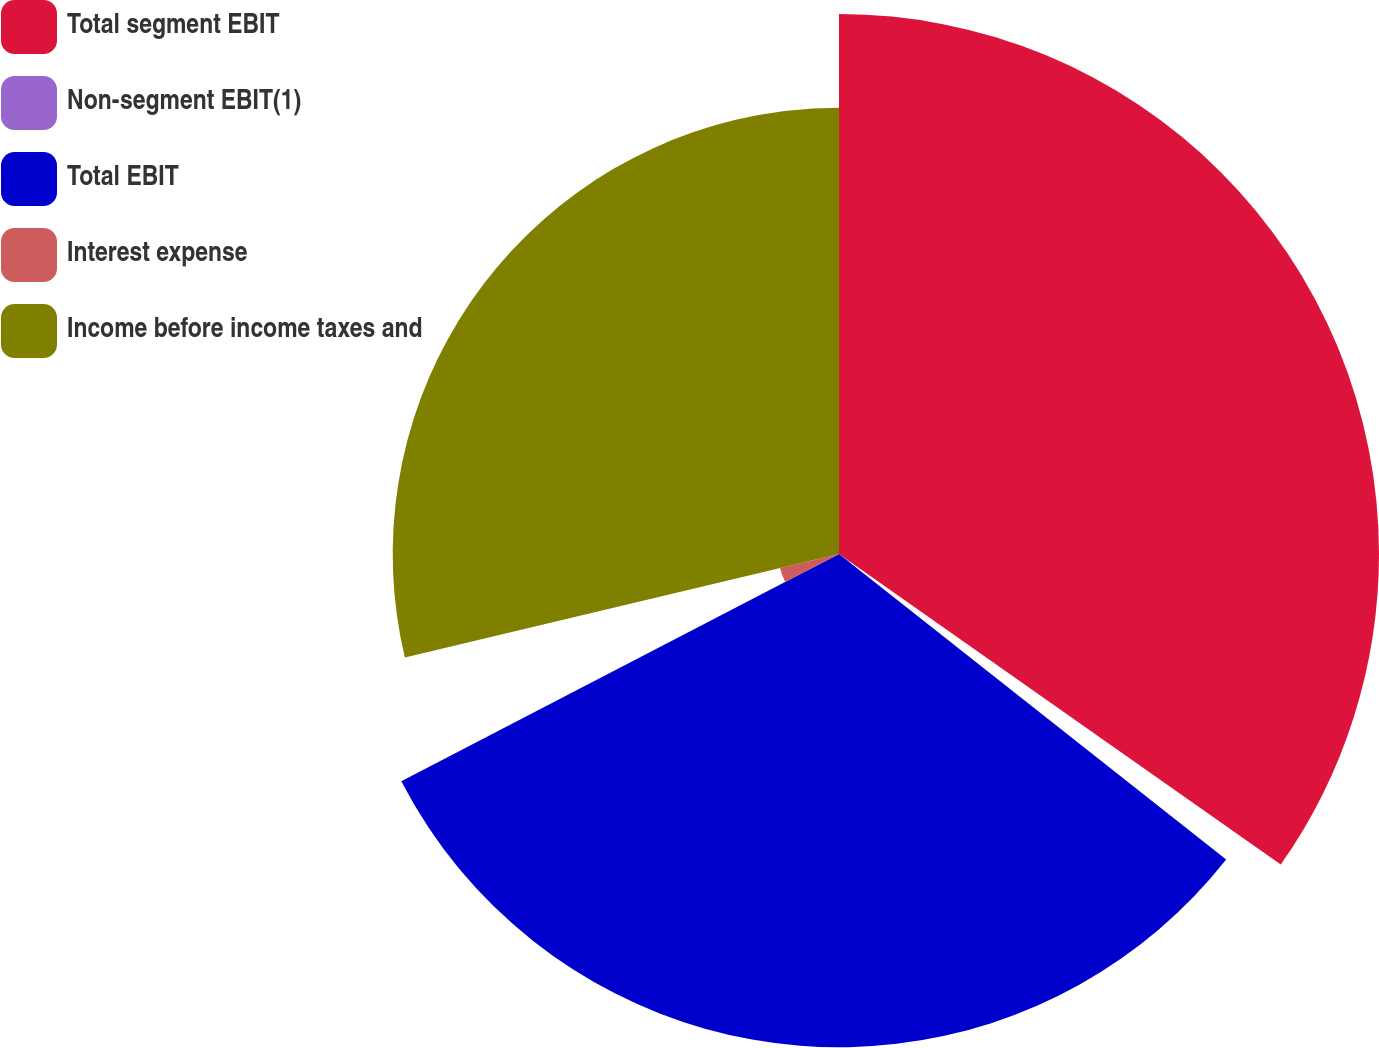Convert chart. <chart><loc_0><loc_0><loc_500><loc_500><pie_chart><fcel>Total segment EBIT<fcel>Non-segment EBIT(1)<fcel>Total EBIT<fcel>Interest expense<fcel>Income before income taxes and<nl><fcel>34.75%<fcel>0.88%<fcel>31.74%<fcel>3.9%<fcel>28.72%<nl></chart> 